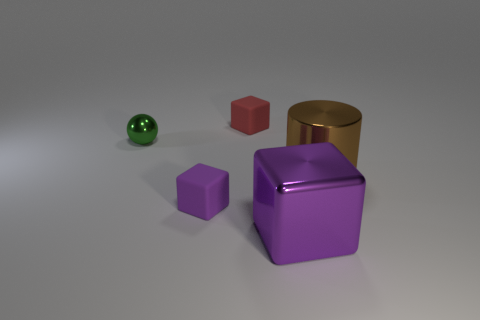Subtract 1 cubes. How many cubes are left? 2 Add 2 tiny brown matte objects. How many objects exist? 7 Subtract all blocks. How many objects are left? 2 Add 1 big gray matte cubes. How many big gray matte cubes exist? 1 Subtract 0 green blocks. How many objects are left? 5 Subtract all shiny objects. Subtract all big blue matte things. How many objects are left? 2 Add 5 tiny green objects. How many tiny green objects are left? 6 